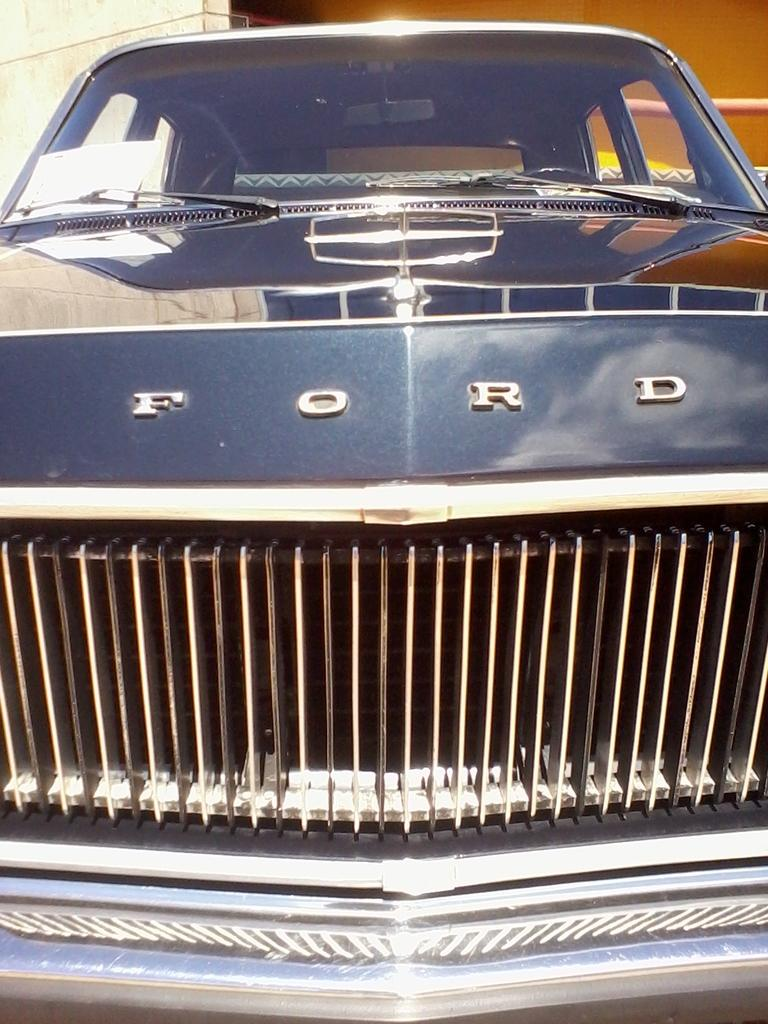What is the main subject of the image? The main subject of the image is a car. Can you describe any specific details about the car? Yes, there is writing on the front side of the car. What can be seen in the background of the image? There is a building in the background of the image. How does the car help the police solve a case in the image? There is no mention of a police case or any police involvement in the image. The image only shows a car with writing on the front side and a building in the background. 